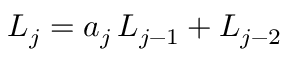<formula> <loc_0><loc_0><loc_500><loc_500>L _ { j } = a _ { j } \, L _ { j - 1 } + L _ { j - 2 }</formula> 